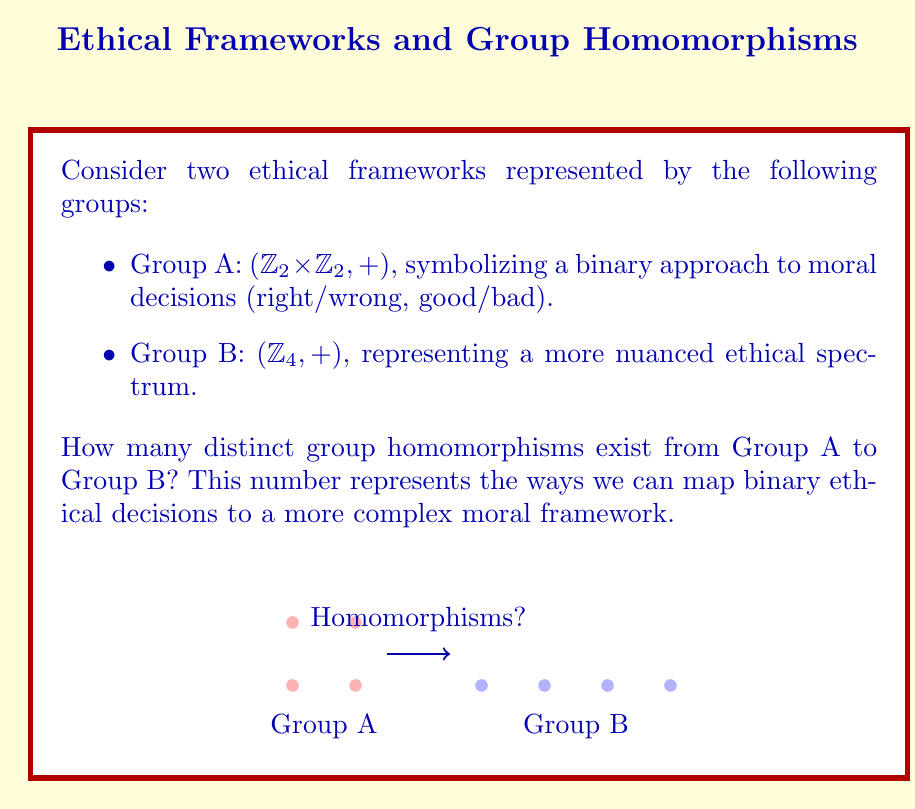Solve this math problem. To find the number of group homomorphisms from $A = \mathbb{Z}_2 \times \mathbb{Z}_2$ to $B = \mathbb{Z}_4$, we follow these steps:

1) First, recall that a homomorphism $\phi: A \to B$ must satisfy $\phi(a + a') = \phi(a) + \phi(a')$ for all $a, a' \in A$.

2) Group A is generated by $(1,0)$ and $(0,1)$. So, we only need to determine $\phi(1,0)$ and $\phi(0,1)$ to fully define a homomorphism.

3) In $\mathbb{Z}_2 \times \mathbb{Z}_2$, all elements have order 2 (except the identity). This means:
   $$(1,0) + (1,0) = (0,0)$$
   $$(0,1) + (0,1) = (0,0)$$

4) For the homomorphism property to hold:
   $$\phi((1,0) + (1,0)) = \phi(1,0) + \phi(1,0) = \phi(0,0) = 0$$
   $$\phi((0,1) + (0,1)) = \phi(0,1) + \phi(0,1) = \phi(0,0) = 0$$

5) In $\mathbb{Z}_4$, the only elements that satisfy $x + x = 0$ are 0 and 2.

6) Therefore, $\phi(1,0)$ and $\phi(0,1)$ can each be either 0 or 2 in $\mathbb{Z}_4$.

7) This gives us 4 possible combinations for $(\phi(1,0), \phi(0,1))$:
   (0,0), (0,2), (2,0), (2,2)

8) Each of these combinations defines a unique homomorphism.
Answer: 4 